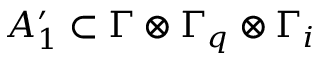Convert formula to latex. <formula><loc_0><loc_0><loc_500><loc_500>A _ { 1 } ^ { \prime } \subset \Gamma \otimes \Gamma _ { q } \otimes \Gamma _ { i }</formula> 